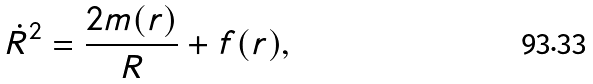<formula> <loc_0><loc_0><loc_500><loc_500>\dot { R } ^ { 2 } = \frac { 2 m ( r ) } R + f ( r ) ,</formula> 